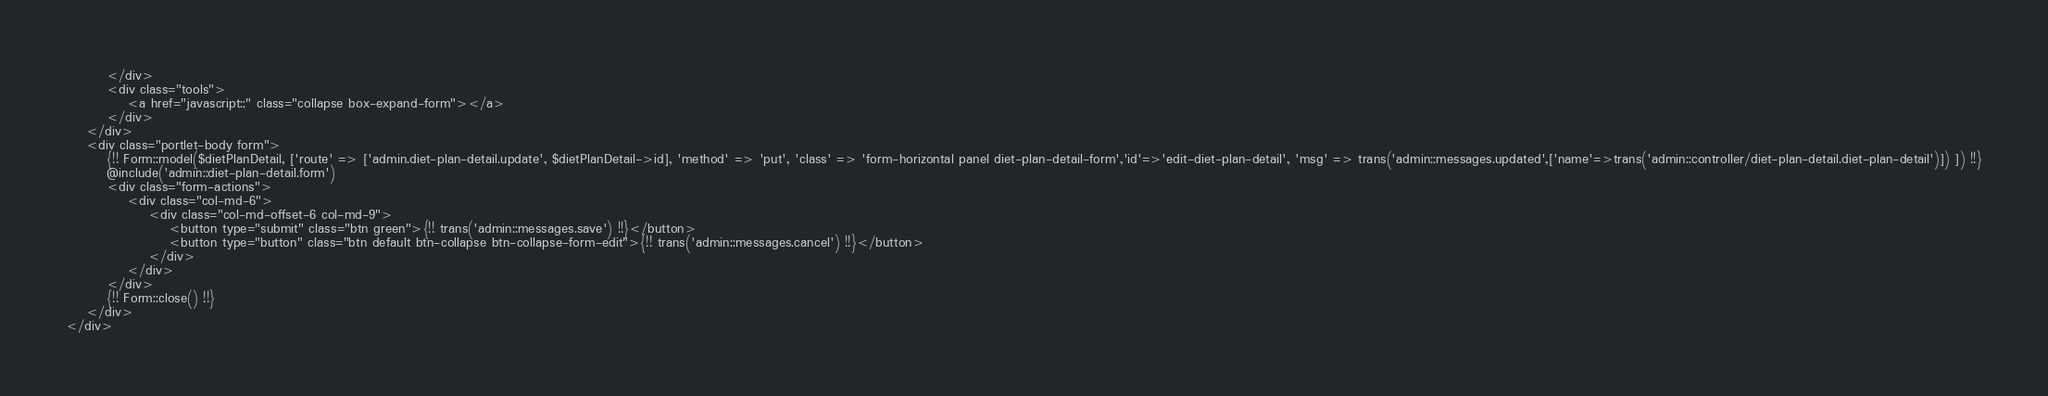<code> <loc_0><loc_0><loc_500><loc_500><_PHP_>        </div>
        <div class="tools">
            <a href="javascript:;" class="collapse box-expand-form"></a>
        </div>
    </div>
    <div class="portlet-body form">
        {!! Form::model($dietPlanDetail, ['route' => ['admin.diet-plan-detail.update', $dietPlanDetail->id], 'method' => 'put', 'class' => 'form-horizontal panel diet-plan-detail-form','id'=>'edit-diet-plan-detail', 'msg' => trans('admin::messages.updated',['name'=>trans('admin::controller/diet-plan-detail.diet-plan-detail')]) ]) !!}
        @include('admin::diet-plan-detail.form')
        <div class="form-actions">
            <div class="col-md-6">
                <div class="col-md-offset-6 col-md-9">
                    <button type="submit" class="btn green">{!! trans('admin::messages.save') !!}</button>
                    <button type="button" class="btn default btn-collapse btn-collapse-form-edit">{!! trans('admin::messages.cancel') !!}</button>
                </div>
            </div>
        </div>
        {!! Form::close() !!}
    </div>
</div></code> 